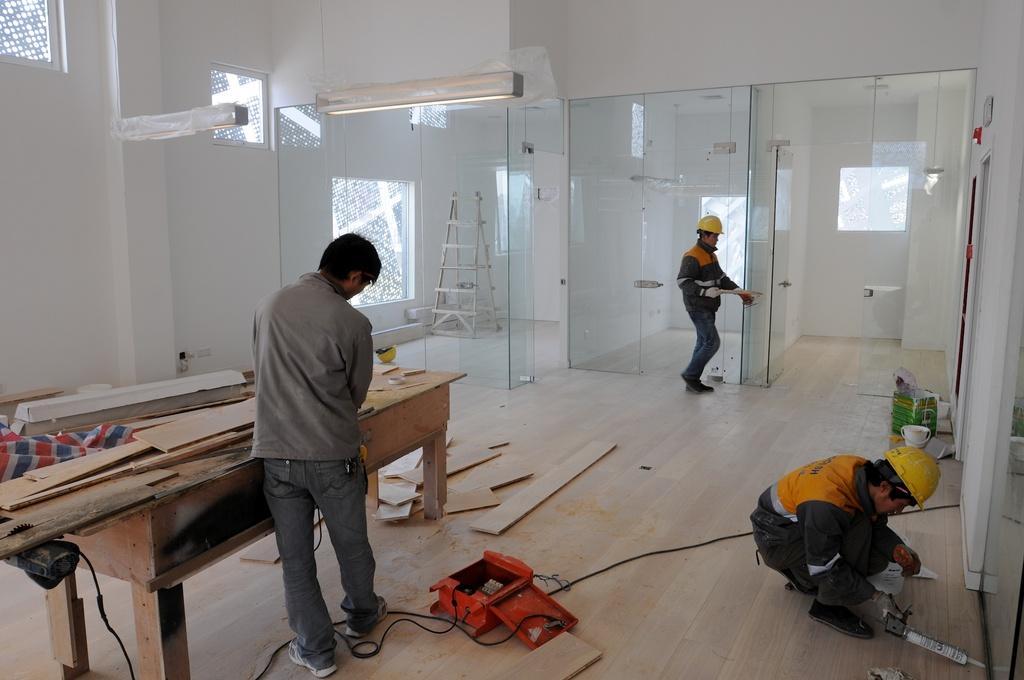Can you describe this image briefly? In this picture we can see men working. We can see this two men wearing helmets. On the floor we can see wood parts, machine, white bucket and other objects. Here we can see glass doors. This is a ladder. 